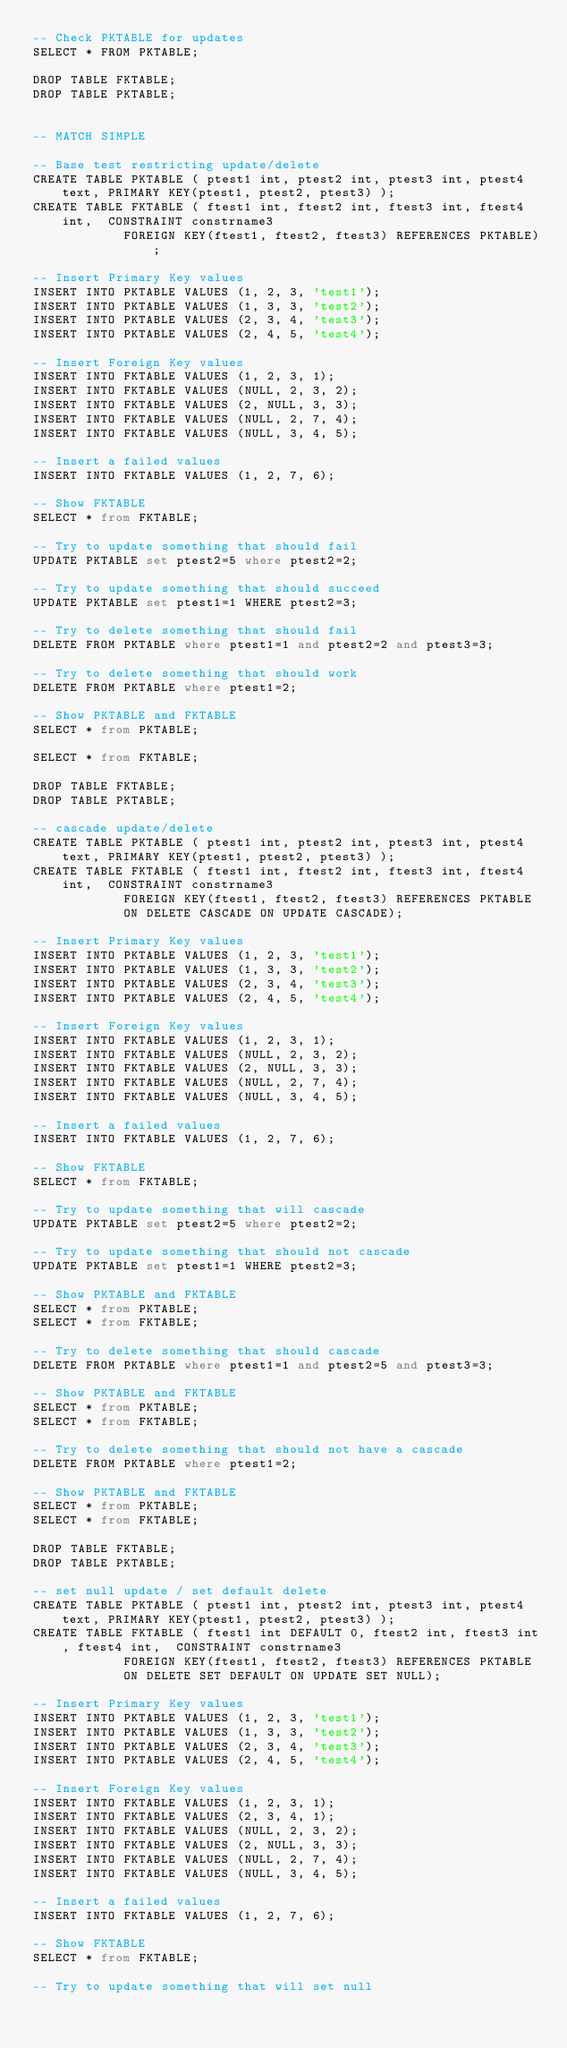Convert code to text. <code><loc_0><loc_0><loc_500><loc_500><_SQL_>-- Check PKTABLE for updates
SELECT * FROM PKTABLE;

DROP TABLE FKTABLE;
DROP TABLE PKTABLE;


-- MATCH SIMPLE

-- Base test restricting update/delete
CREATE TABLE PKTABLE ( ptest1 int, ptest2 int, ptest3 int, ptest4 text, PRIMARY KEY(ptest1, ptest2, ptest3) );
CREATE TABLE FKTABLE ( ftest1 int, ftest2 int, ftest3 int, ftest4 int,  CONSTRAINT constrname3
			FOREIGN KEY(ftest1, ftest2, ftest3) REFERENCES PKTABLE);

-- Insert Primary Key values
INSERT INTO PKTABLE VALUES (1, 2, 3, 'test1');
INSERT INTO PKTABLE VALUES (1, 3, 3, 'test2');
INSERT INTO PKTABLE VALUES (2, 3, 4, 'test3');
INSERT INTO PKTABLE VALUES (2, 4, 5, 'test4');

-- Insert Foreign Key values
INSERT INTO FKTABLE VALUES (1, 2, 3, 1);
INSERT INTO FKTABLE VALUES (NULL, 2, 3, 2);
INSERT INTO FKTABLE VALUES (2, NULL, 3, 3);
INSERT INTO FKTABLE VALUES (NULL, 2, 7, 4);
INSERT INTO FKTABLE VALUES (NULL, 3, 4, 5);

-- Insert a failed values
INSERT INTO FKTABLE VALUES (1, 2, 7, 6);

-- Show FKTABLE
SELECT * from FKTABLE;

-- Try to update something that should fail
UPDATE PKTABLE set ptest2=5 where ptest2=2;

-- Try to update something that should succeed
UPDATE PKTABLE set ptest1=1 WHERE ptest2=3;

-- Try to delete something that should fail
DELETE FROM PKTABLE where ptest1=1 and ptest2=2 and ptest3=3;

-- Try to delete something that should work
DELETE FROM PKTABLE where ptest1=2;

-- Show PKTABLE and FKTABLE
SELECT * from PKTABLE;

SELECT * from FKTABLE;

DROP TABLE FKTABLE;
DROP TABLE PKTABLE;

-- cascade update/delete
CREATE TABLE PKTABLE ( ptest1 int, ptest2 int, ptest3 int, ptest4 text, PRIMARY KEY(ptest1, ptest2, ptest3) );
CREATE TABLE FKTABLE ( ftest1 int, ftest2 int, ftest3 int, ftest4 int,  CONSTRAINT constrname3
			FOREIGN KEY(ftest1, ftest2, ftest3) REFERENCES PKTABLE
			ON DELETE CASCADE ON UPDATE CASCADE);

-- Insert Primary Key values
INSERT INTO PKTABLE VALUES (1, 2, 3, 'test1');
INSERT INTO PKTABLE VALUES (1, 3, 3, 'test2');
INSERT INTO PKTABLE VALUES (2, 3, 4, 'test3');
INSERT INTO PKTABLE VALUES (2, 4, 5, 'test4');

-- Insert Foreign Key values
INSERT INTO FKTABLE VALUES (1, 2, 3, 1);
INSERT INTO FKTABLE VALUES (NULL, 2, 3, 2);
INSERT INTO FKTABLE VALUES (2, NULL, 3, 3);
INSERT INTO FKTABLE VALUES (NULL, 2, 7, 4);
INSERT INTO FKTABLE VALUES (NULL, 3, 4, 5);

-- Insert a failed values
INSERT INTO FKTABLE VALUES (1, 2, 7, 6);

-- Show FKTABLE
SELECT * from FKTABLE;

-- Try to update something that will cascade
UPDATE PKTABLE set ptest2=5 where ptest2=2;

-- Try to update something that should not cascade
UPDATE PKTABLE set ptest1=1 WHERE ptest2=3;

-- Show PKTABLE and FKTABLE
SELECT * from PKTABLE;
SELECT * from FKTABLE;

-- Try to delete something that should cascade
DELETE FROM PKTABLE where ptest1=1 and ptest2=5 and ptest3=3;

-- Show PKTABLE and FKTABLE
SELECT * from PKTABLE;
SELECT * from FKTABLE;

-- Try to delete something that should not have a cascade
DELETE FROM PKTABLE where ptest1=2;

-- Show PKTABLE and FKTABLE
SELECT * from PKTABLE;
SELECT * from FKTABLE;

DROP TABLE FKTABLE;
DROP TABLE PKTABLE;

-- set null update / set default delete
CREATE TABLE PKTABLE ( ptest1 int, ptest2 int, ptest3 int, ptest4 text, PRIMARY KEY(ptest1, ptest2, ptest3) );
CREATE TABLE FKTABLE ( ftest1 int DEFAULT 0, ftest2 int, ftest3 int, ftest4 int,  CONSTRAINT constrname3
			FOREIGN KEY(ftest1, ftest2, ftest3) REFERENCES PKTABLE
			ON DELETE SET DEFAULT ON UPDATE SET NULL);

-- Insert Primary Key values
INSERT INTO PKTABLE VALUES (1, 2, 3, 'test1');
INSERT INTO PKTABLE VALUES (1, 3, 3, 'test2');
INSERT INTO PKTABLE VALUES (2, 3, 4, 'test3');
INSERT INTO PKTABLE VALUES (2, 4, 5, 'test4');

-- Insert Foreign Key values
INSERT INTO FKTABLE VALUES (1, 2, 3, 1);
INSERT INTO FKTABLE VALUES (2, 3, 4, 1);
INSERT INTO FKTABLE VALUES (NULL, 2, 3, 2);
INSERT INTO FKTABLE VALUES (2, NULL, 3, 3);
INSERT INTO FKTABLE VALUES (NULL, 2, 7, 4);
INSERT INTO FKTABLE VALUES (NULL, 3, 4, 5);

-- Insert a failed values
INSERT INTO FKTABLE VALUES (1, 2, 7, 6);

-- Show FKTABLE
SELECT * from FKTABLE;

-- Try to update something that will set null</code> 